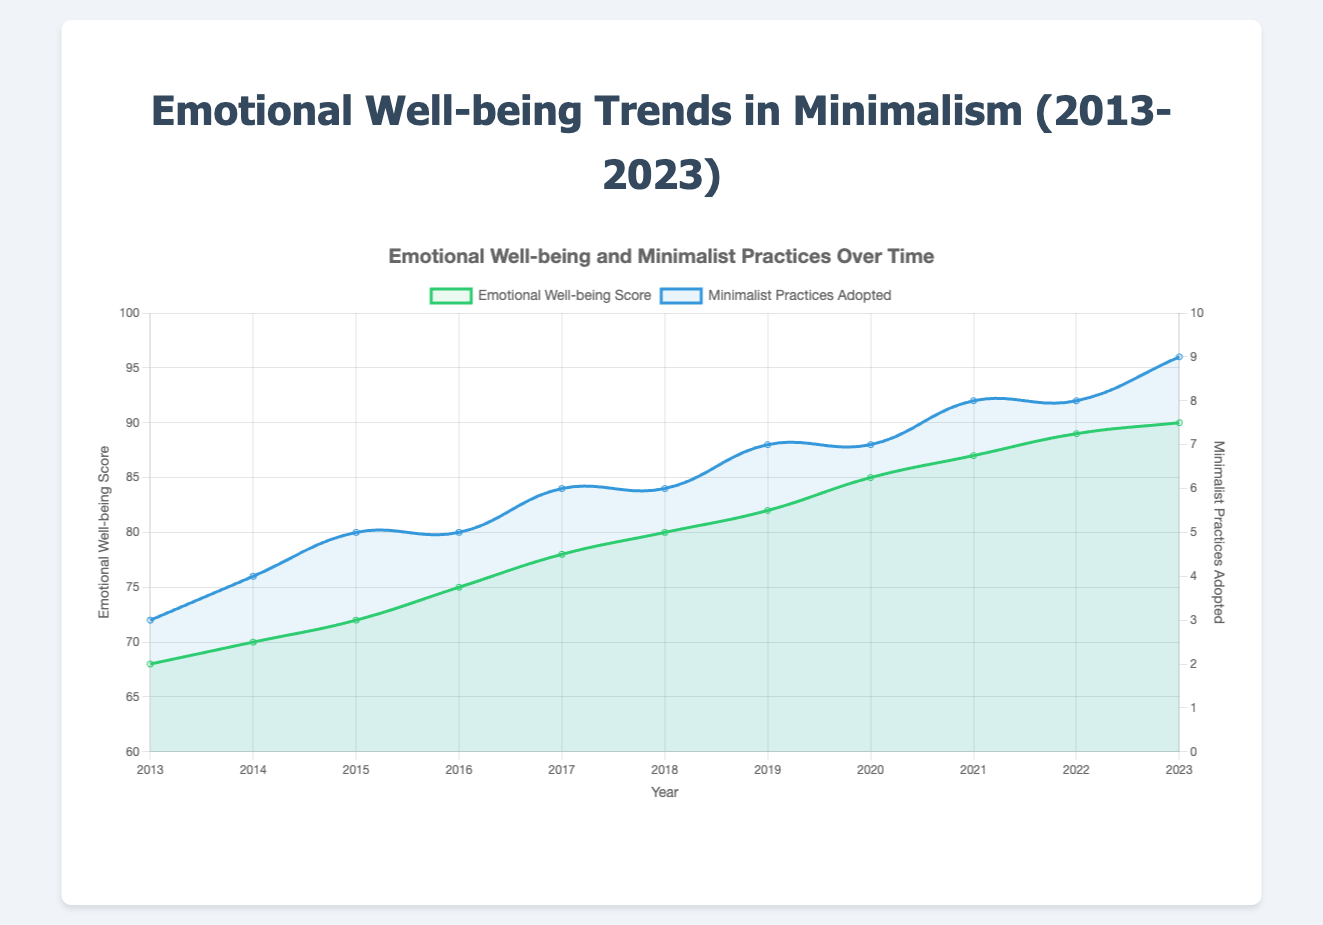What is the overall trend in the emotional well-being score from 2013 to 2023? The emotional well-being score shows a positive trend from 2013 to 2023, gradually increasing from 68 to 90. This implies a consistent improvement in emotional well-being over the decade.
Answer: Increasing trend In which year did the emotional well-being score first reach 80? The emotional well-being score first reached or exceeded 80 in the year 2018, where it recorded a score of 80.
Answer: 2018 How many additional minimalist practices were adopted from 2013 to 2023? In 2013, the number of minimalist practices adopted was 3, and in 2023, it was 9. The difference is 9 - 3 = 6.
Answer: 6 Which year had the largest increase in emotional well-being score compared to the previous year? By calculating the yearly differences: 
2014 - 2013 = 2, 
2015 - 2014 = 2, 
2016 - 2015 = 3, 
2017 - 2016 = 3, 
2018 - 2017 = 2, 
2019 - 2018 = 2, 
2020 - 2019 = 3, 
2021 - 2020 = 2, 
2022 - 2021 = 2, 
2023 - 2022 = 1.
The largest increase is 3, occurring in 2016, 2020, and 2017.
Answer: 2016 and 2020 and 2017 Do emotional well-being scores and the number of minimalist practices adopted show a correlation? Both the emotional well-being scores and the number of minimalist practices adopted exhibit an increasing trend from 2013 to 2023. This visual correlation suggests that as more minimalist practices are adopted, the emotional well-being score tends to increase.
Answer: Yes What is the total emotional well-being score when summed over all years from 2013 to 2023? Summing up the scores: 
68 + 70 + 72 + 75 + 78 + 80 + 82 + 85 + 87 + 89 + 90 = 876.
Answer: 876 Which had a steeper increase over the decade, emotional well-being scores or minimalist practices adopted? The emotional well-being score increased from 68 to 90, a difference of 22. Minimalist practices adopted increased from 3 to 9, a difference of 6. Comparatively, the emotional well-being scores had a greater absolute increase over the decade.
Answer: Emotional well-being scores By what percentage did the emotional well-being score increase from 2013 to 2023? The percentage increase is calculated as ((90 - 68) / 68) * 100 = 32.35%.
Answer: 32.35% How many years did the number of minimalist practices adopted remain constant? The number of minimalist practices adopted remained constant in the years 2016-2017, 2018-2019, and 2021-2022, which are three periods. Counting these periods only once gives years: 2 (2016, 2018, 2021-2022).
Answer: 3 years What can be inferred about the year 2016 based on the visual attributes of the plot? The year 2016 marks a significant point with an increase in the emotional well-being score (from 72 to 75) and the minimalist practices adopted again averaged the same as before but with total consistency. Visual attributes show that it was a year of sustained growth in emotional practices.
Answer: Consistent year 